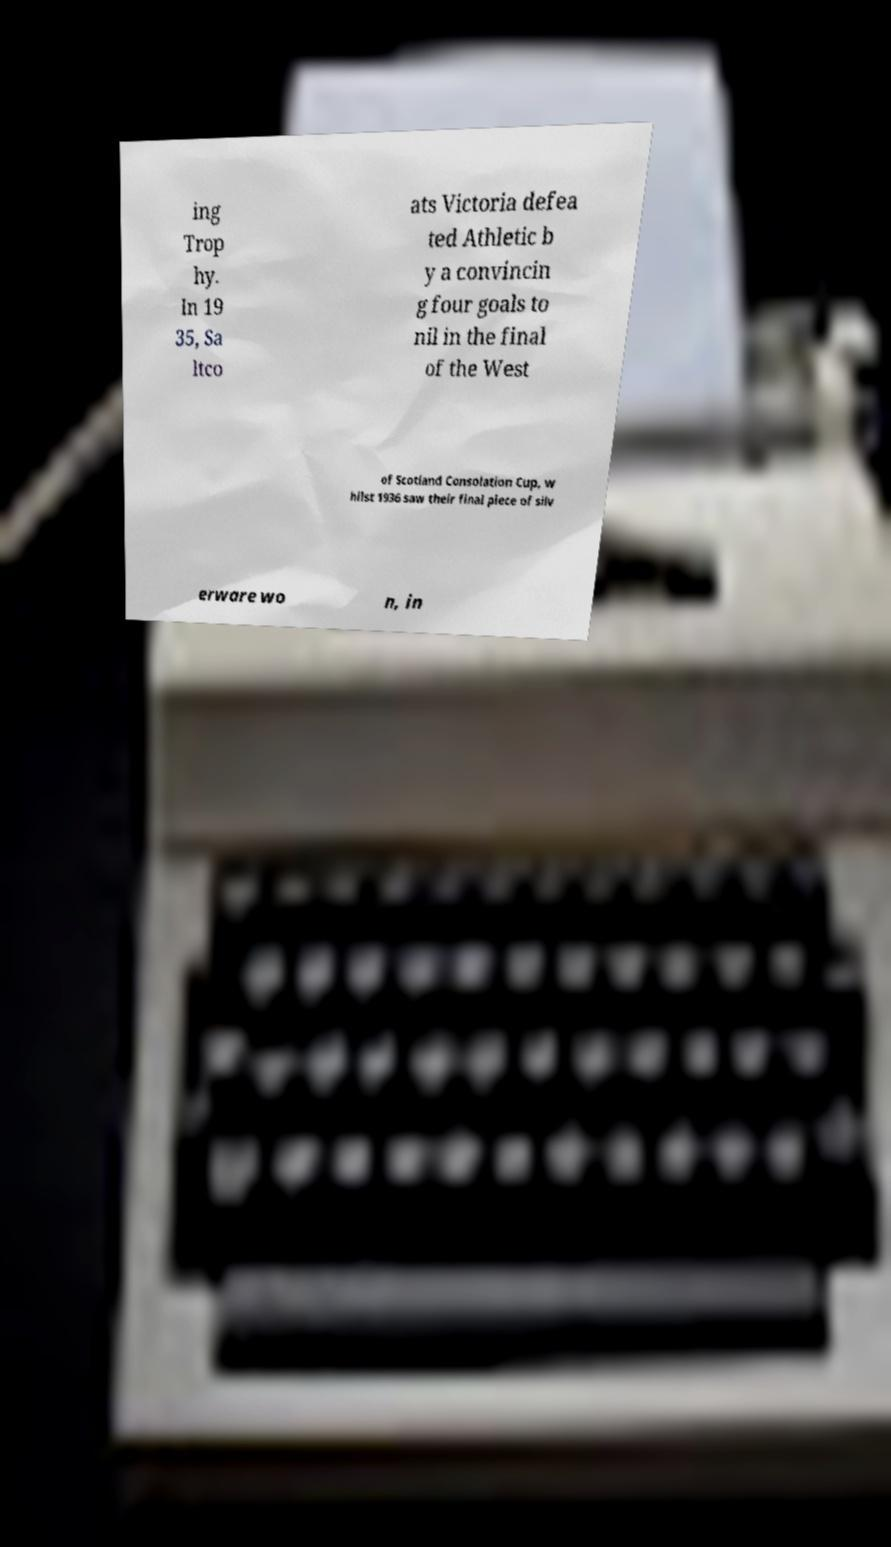There's text embedded in this image that I need extracted. Can you transcribe it verbatim? ing Trop hy. In 19 35, Sa ltco ats Victoria defea ted Athletic b y a convincin g four goals to nil in the final of the West of Scotland Consolation Cup, w hilst 1936 saw their final piece of silv erware wo n, in 